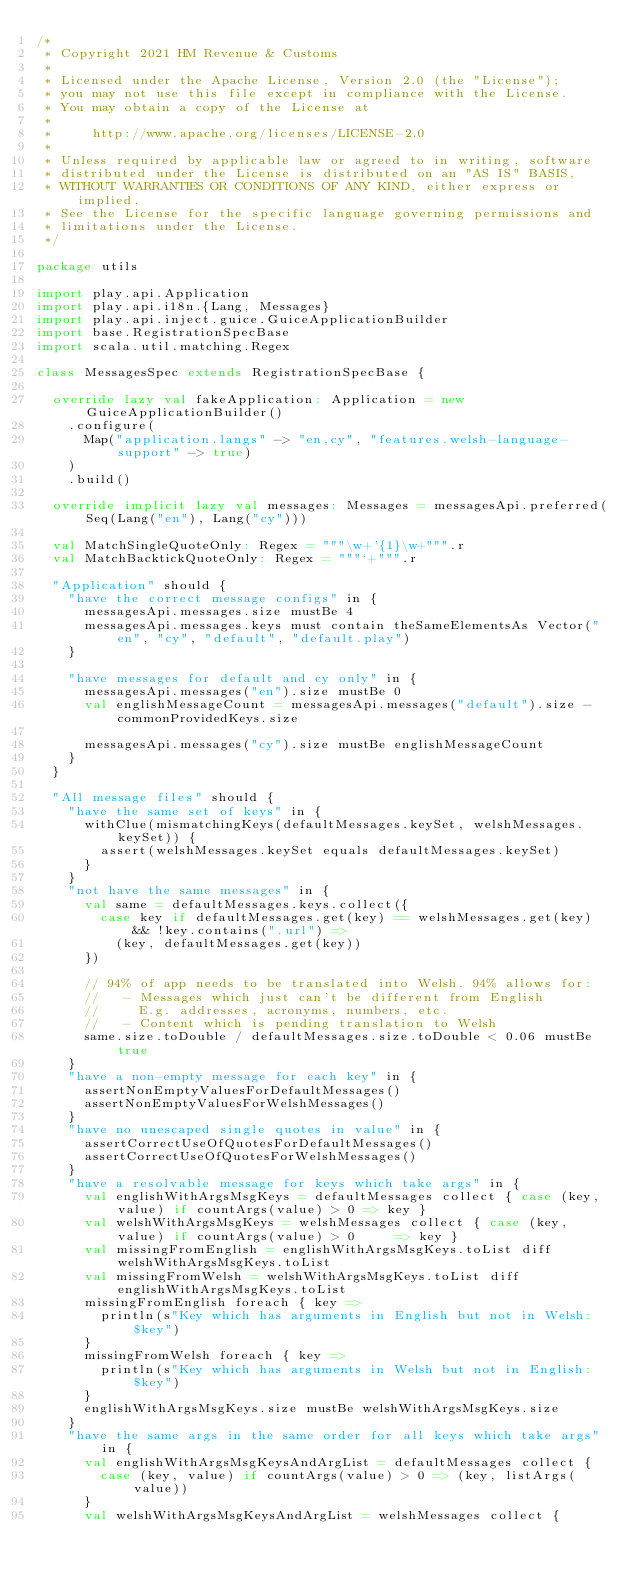<code> <loc_0><loc_0><loc_500><loc_500><_Scala_>/*
 * Copyright 2021 HM Revenue & Customs
 *
 * Licensed under the Apache License, Version 2.0 (the "License");
 * you may not use this file except in compliance with the License.
 * You may obtain a copy of the License at
 *
 *     http://www.apache.org/licenses/LICENSE-2.0
 *
 * Unless required by applicable law or agreed to in writing, software
 * distributed under the License is distributed on an "AS IS" BASIS,
 * WITHOUT WARRANTIES OR CONDITIONS OF ANY KIND, either express or implied.
 * See the License for the specific language governing permissions and
 * limitations under the License.
 */

package utils

import play.api.Application
import play.api.i18n.{Lang, Messages}
import play.api.inject.guice.GuiceApplicationBuilder
import base.RegistrationSpecBase
import scala.util.matching.Regex

class MessagesSpec extends RegistrationSpecBase {

  override lazy val fakeApplication: Application = new GuiceApplicationBuilder()
    .configure(
      Map("application.langs" -> "en,cy", "features.welsh-language-support" -> true)
    )
    .build()

  override implicit lazy val messages: Messages = messagesApi.preferred(Seq(Lang("en"), Lang("cy")))

  val MatchSingleQuoteOnly: Regex = """\w+'{1}\w+""".r
  val MatchBacktickQuoteOnly: Regex = """`+""".r

  "Application" should {
    "have the correct message configs" in {
      messagesApi.messages.size mustBe 4
      messagesApi.messages.keys must contain theSameElementsAs Vector("en", "cy", "default", "default.play")
    }

    "have messages for default and cy only" in {
      messagesApi.messages("en").size mustBe 0
      val englishMessageCount = messagesApi.messages("default").size - commonProvidedKeys.size

      messagesApi.messages("cy").size mustBe englishMessageCount
    }
  }

  "All message files" should {
    "have the same set of keys" in {
      withClue(mismatchingKeys(defaultMessages.keySet, welshMessages.keySet)) {
        assert(welshMessages.keySet equals defaultMessages.keySet)
      }
    }
    "not have the same messages" in {
      val same = defaultMessages.keys.collect({
        case key if defaultMessages.get(key) == welshMessages.get(key) && !key.contains(".url") =>
          (key, defaultMessages.get(key))
      })

      // 94% of app needs to be translated into Welsh. 94% allows for:
      //   - Messages which just can't be different from English
      //     E.g. addresses, acronyms, numbers, etc.
      //   - Content which is pending translation to Welsh
      same.size.toDouble / defaultMessages.size.toDouble < 0.06 mustBe true
    }
    "have a non-empty message for each key" in {
      assertNonEmptyValuesForDefaultMessages()
      assertNonEmptyValuesForWelshMessages()
    }
    "have no unescaped single quotes in value" in {
      assertCorrectUseOfQuotesForDefaultMessages()
      assertCorrectUseOfQuotesForWelshMessages()
    }
    "have a resolvable message for keys which take args" in {
      val englishWithArgsMsgKeys = defaultMessages collect { case (key, value) if countArgs(value) > 0 => key }
      val welshWithArgsMsgKeys = welshMessages collect { case (key, value) if countArgs(value) > 0     => key }
      val missingFromEnglish = englishWithArgsMsgKeys.toList diff welshWithArgsMsgKeys.toList
      val missingFromWelsh = welshWithArgsMsgKeys.toList diff englishWithArgsMsgKeys.toList
      missingFromEnglish foreach { key =>
        println(s"Key which has arguments in English but not in Welsh: $key")
      }
      missingFromWelsh foreach { key =>
        println(s"Key which has arguments in Welsh but not in English: $key")
      }
      englishWithArgsMsgKeys.size mustBe welshWithArgsMsgKeys.size
    }
    "have the same args in the same order for all keys which take args" in {
      val englishWithArgsMsgKeysAndArgList = defaultMessages collect {
        case (key, value) if countArgs(value) > 0 => (key, listArgs(value))
      }
      val welshWithArgsMsgKeysAndArgList = welshMessages collect {</code> 